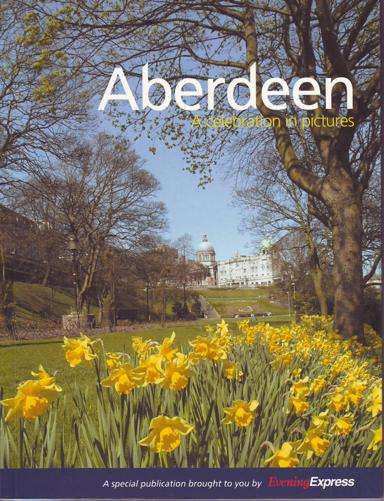What is the title of the special publication mentioned in the image? The title of the special publication shown in the image is "Aberdeen: A Celebration in Pictures." This visually engaging publication showcases notable sights and scenes from Aberdeen, focusing on its vibrant natural beauty and architectural landmarks. 